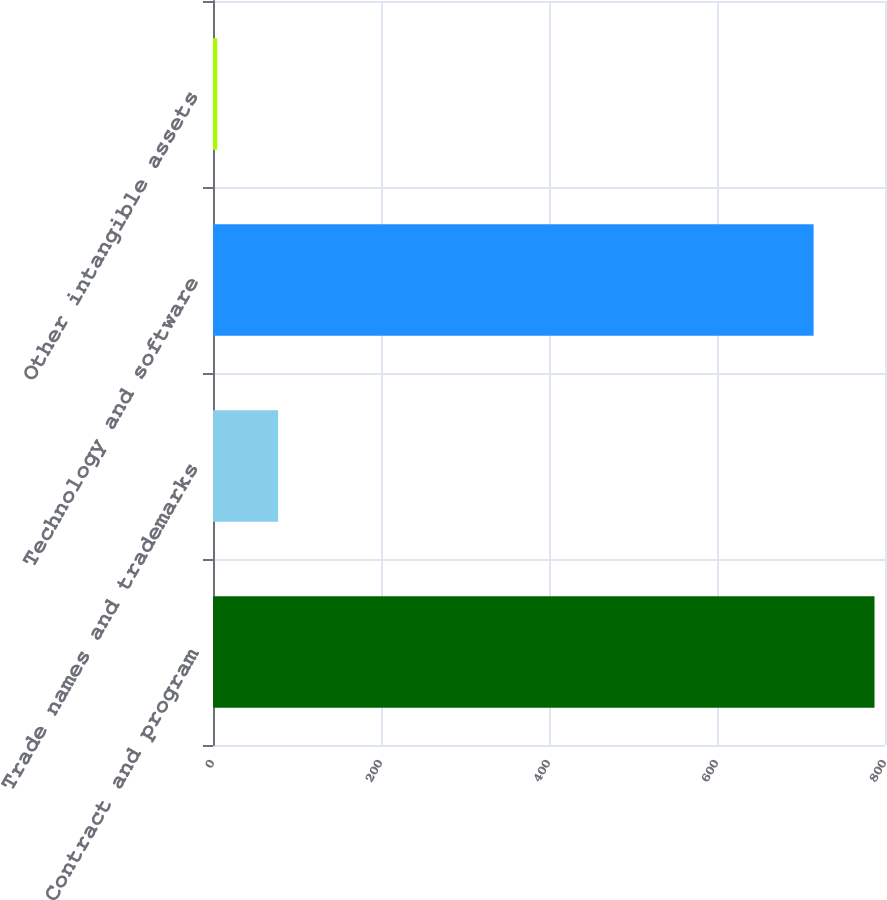<chart> <loc_0><loc_0><loc_500><loc_500><bar_chart><fcel>Contract and program<fcel>Trade names and trademarks<fcel>Technology and software<fcel>Other intangible assets<nl><fcel>787.5<fcel>77.5<fcel>715<fcel>5<nl></chart> 